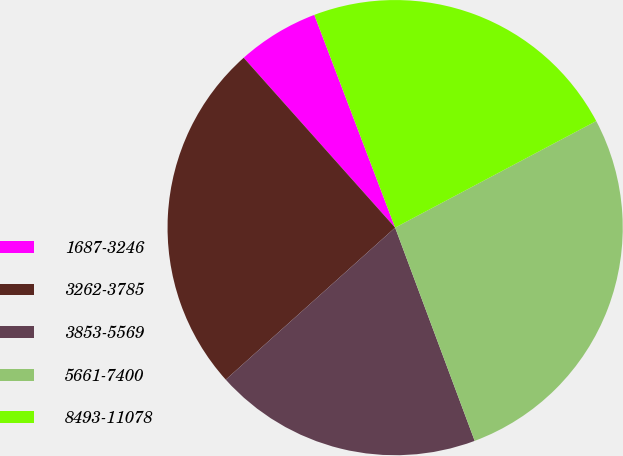Convert chart to OTSL. <chart><loc_0><loc_0><loc_500><loc_500><pie_chart><fcel>1687-3246<fcel>3262-3785<fcel>3853-5569<fcel>5661-7400<fcel>8493-11078<nl><fcel>5.81%<fcel>25.05%<fcel>19.04%<fcel>27.07%<fcel>23.02%<nl></chart> 